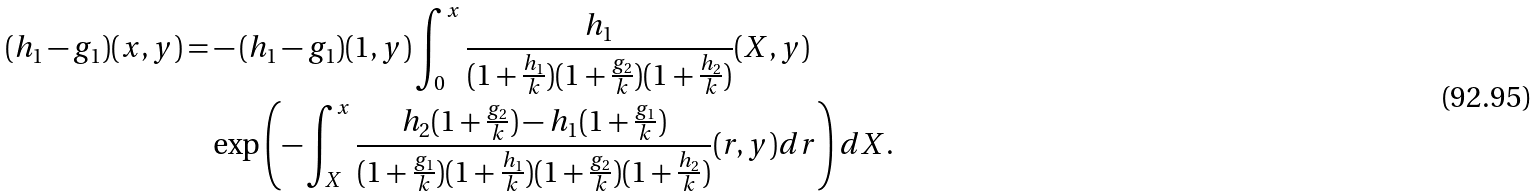Convert formula to latex. <formula><loc_0><loc_0><loc_500><loc_500>( h _ { 1 } - g _ { 1 } ) ( x , y ) = & - ( h _ { 1 } - g _ { 1 } ) ( 1 , y ) \int _ { 0 } ^ { x } \frac { h _ { 1 } } { ( 1 + \frac { h _ { 1 } } { k } ) ( 1 + \frac { g _ { 2 } } { k } ) ( 1 + \frac { h _ { 2 } } { k } ) } ( X , y ) \\ & \exp \left ( - \int _ { X } ^ { x } \frac { h _ { 2 } ( 1 + \frac { g _ { 2 } } { k } ) - h _ { 1 } ( 1 + \frac { g _ { 1 } } { k } ) } { ( 1 + \frac { g _ { 1 } } { k } ) ( 1 + \frac { h _ { 1 } } { k } ) ( 1 + \frac { g _ { 2 } } { k } ) ( 1 + \frac { h _ { 2 } } { k } ) } ( r , y ) d r \right ) d X .</formula> 